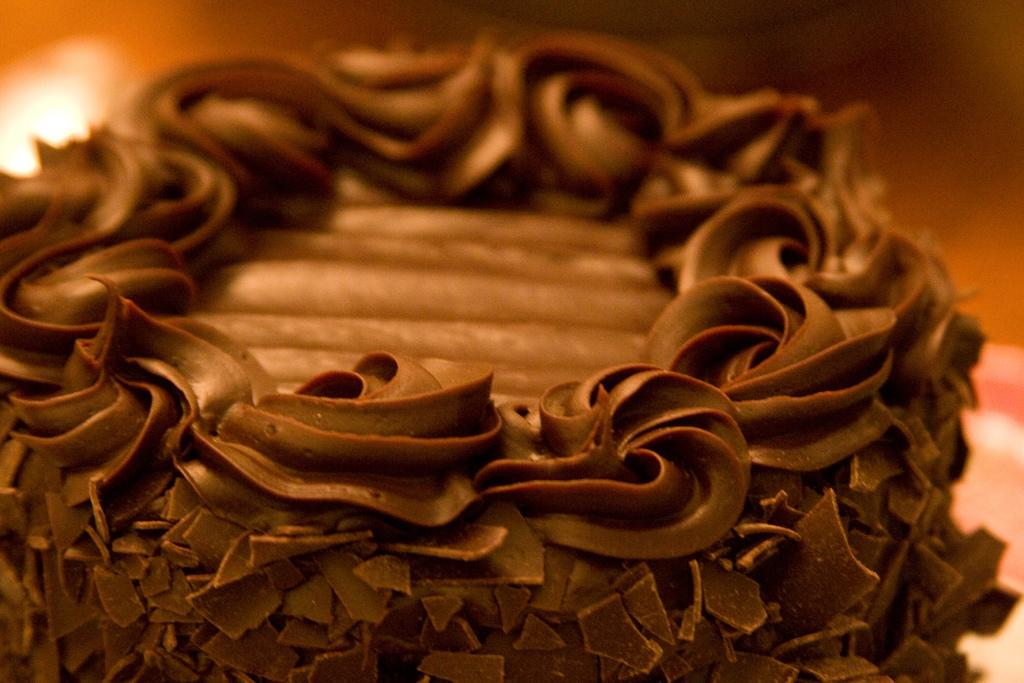What can be seen in the image? There is food in the image. Can you describe the background of the image? The background of the image is blurred. What letter is being rubbed on the bells in the image? There are no letters or bells present in the image. 